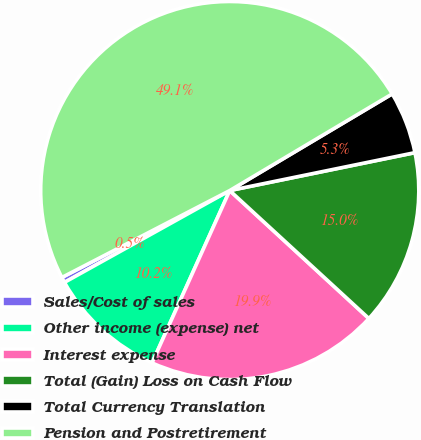Convert chart to OTSL. <chart><loc_0><loc_0><loc_500><loc_500><pie_chart><fcel>Sales/Cost of sales<fcel>Other income (expense) net<fcel>Interest expense<fcel>Total (Gain) Loss on Cash Flow<fcel>Total Currency Translation<fcel>Pension and Postretirement<nl><fcel>0.47%<fcel>10.19%<fcel>19.91%<fcel>15.05%<fcel>5.33%<fcel>49.07%<nl></chart> 